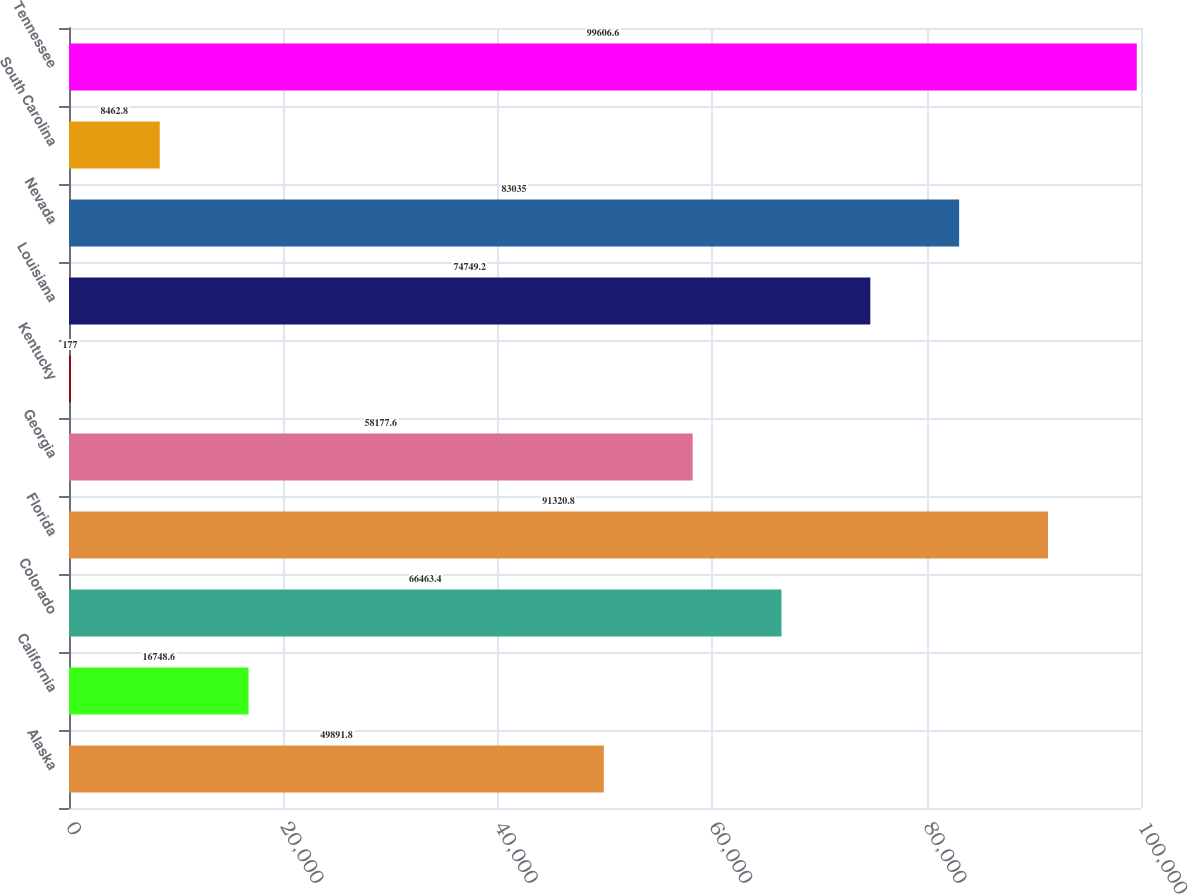Convert chart to OTSL. <chart><loc_0><loc_0><loc_500><loc_500><bar_chart><fcel>Alaska<fcel>California<fcel>Colorado<fcel>Florida<fcel>Georgia<fcel>Kentucky<fcel>Louisiana<fcel>Nevada<fcel>South Carolina<fcel>Tennessee<nl><fcel>49891.8<fcel>16748.6<fcel>66463.4<fcel>91320.8<fcel>58177.6<fcel>177<fcel>74749.2<fcel>83035<fcel>8462.8<fcel>99606.6<nl></chart> 